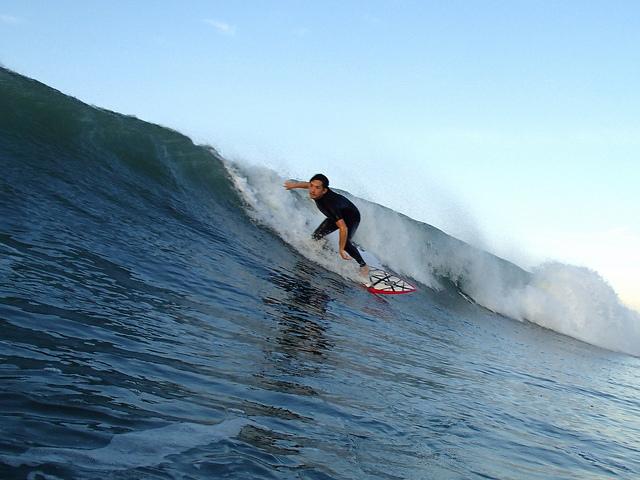Is the guy a good surfer?
Quick response, please. Yes. Are there waves?
Quick response, please. Yes. How many surfers are riding the waves?
Short answer required. 1. 